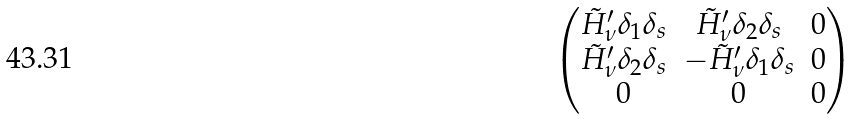Convert formula to latex. <formula><loc_0><loc_0><loc_500><loc_500>\begin{pmatrix} \tilde { H } _ { \nu } ^ { \prime } \delta _ { 1 } \delta _ { s } & \tilde { H } _ { \nu } ^ { \prime } \delta _ { 2 } \delta _ { s } & 0 \\ \tilde { H } _ { \nu } ^ { \prime } \delta _ { 2 } \delta _ { s } & - \tilde { H } _ { \nu } ^ { \prime } \delta _ { 1 } \delta _ { s } & 0 \\ 0 & 0 & 0 \end{pmatrix}</formula> 